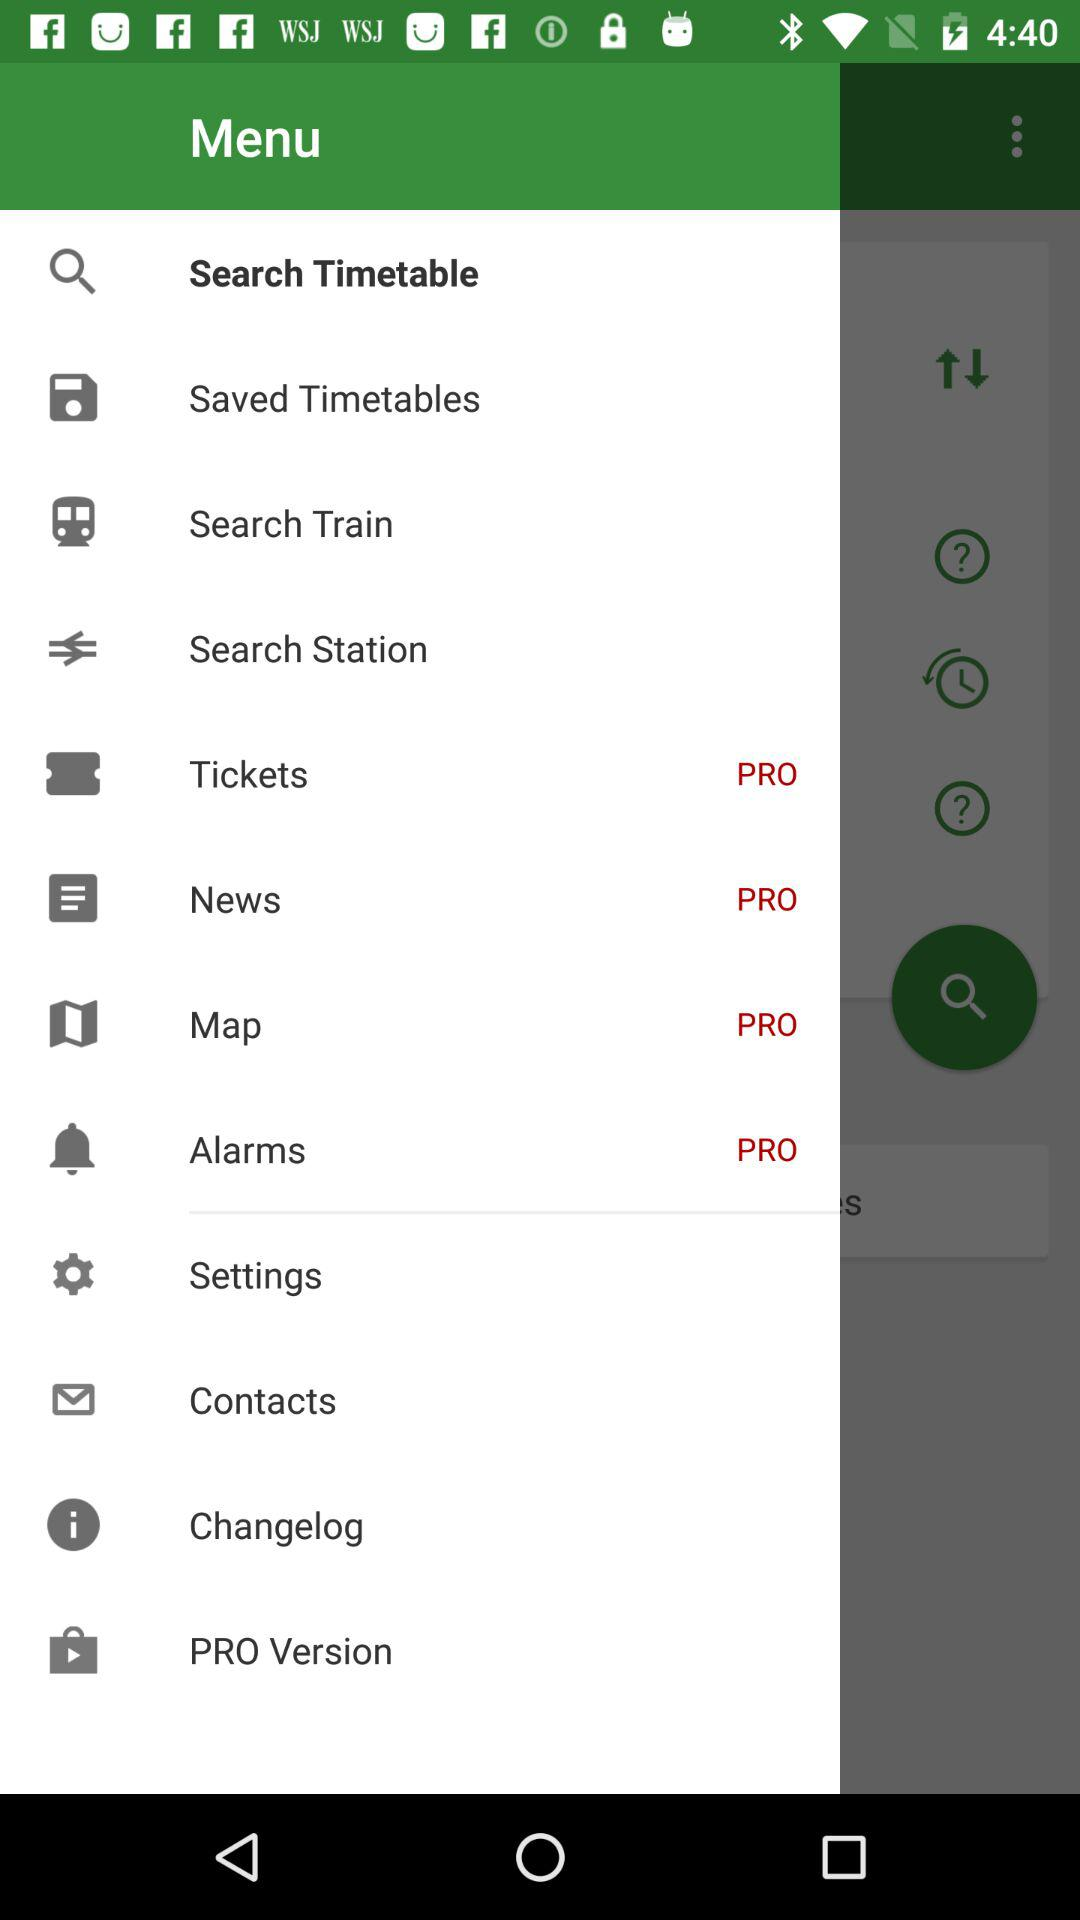Which options have a pro version? There are four options: "Tickets", "News", "Map", and "Alarms". 